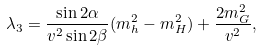Convert formula to latex. <formula><loc_0><loc_0><loc_500><loc_500>\lambda _ { 3 } = \frac { \sin 2 \alpha } { v ^ { 2 } \sin 2 \beta } ( m _ { h } ^ { 2 } - m _ { H } ^ { 2 } ) + \frac { 2 m _ { G } ^ { 2 } } { v ^ { 2 } } ,</formula> 